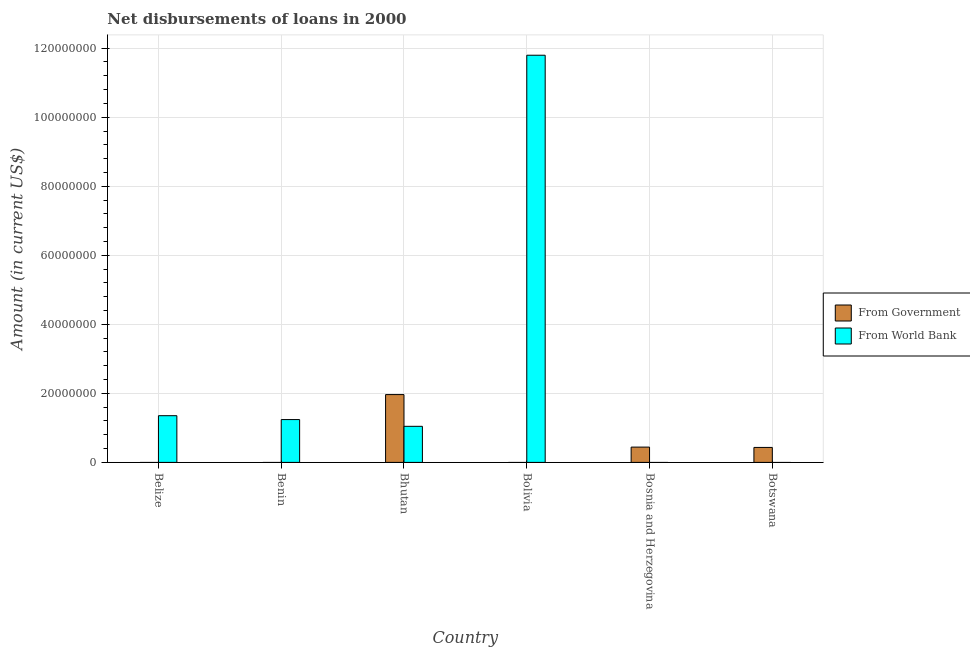Are the number of bars per tick equal to the number of legend labels?
Make the answer very short. No. How many bars are there on the 6th tick from the right?
Provide a succinct answer. 1. What is the label of the 1st group of bars from the left?
Give a very brief answer. Belize. In how many cases, is the number of bars for a given country not equal to the number of legend labels?
Provide a succinct answer. 5. What is the net disbursements of loan from government in Bhutan?
Your response must be concise. 1.96e+07. Across all countries, what is the maximum net disbursements of loan from world bank?
Provide a short and direct response. 1.18e+08. Across all countries, what is the minimum net disbursements of loan from world bank?
Ensure brevity in your answer.  0. In which country was the net disbursements of loan from government maximum?
Provide a short and direct response. Bhutan. What is the total net disbursements of loan from world bank in the graph?
Provide a succinct answer. 1.54e+08. What is the difference between the net disbursements of loan from world bank in Benin and that in Bolivia?
Provide a succinct answer. -1.06e+08. What is the difference between the net disbursements of loan from government in Bolivia and the net disbursements of loan from world bank in Bhutan?
Your answer should be compact. -1.05e+07. What is the average net disbursements of loan from world bank per country?
Give a very brief answer. 2.57e+07. What is the difference between the net disbursements of loan from world bank and net disbursements of loan from government in Bhutan?
Your response must be concise. -9.19e+06. What is the difference between the highest and the second highest net disbursements of loan from government?
Ensure brevity in your answer.  1.52e+07. What is the difference between the highest and the lowest net disbursements of loan from world bank?
Your response must be concise. 1.18e+08. How many bars are there?
Offer a very short reply. 7. Are all the bars in the graph horizontal?
Provide a succinct answer. No. How many countries are there in the graph?
Make the answer very short. 6. What is the difference between two consecutive major ticks on the Y-axis?
Make the answer very short. 2.00e+07. Does the graph contain any zero values?
Your response must be concise. Yes. Where does the legend appear in the graph?
Make the answer very short. Center right. How are the legend labels stacked?
Keep it short and to the point. Vertical. What is the title of the graph?
Offer a very short reply. Net disbursements of loans in 2000. Does "Number of arrivals" appear as one of the legend labels in the graph?
Offer a very short reply. No. What is the label or title of the X-axis?
Provide a succinct answer. Country. What is the Amount (in current US$) of From Government in Belize?
Your response must be concise. 0. What is the Amount (in current US$) in From World Bank in Belize?
Ensure brevity in your answer.  1.35e+07. What is the Amount (in current US$) of From Government in Benin?
Offer a very short reply. 0. What is the Amount (in current US$) in From World Bank in Benin?
Your answer should be very brief. 1.24e+07. What is the Amount (in current US$) in From Government in Bhutan?
Provide a succinct answer. 1.96e+07. What is the Amount (in current US$) in From World Bank in Bhutan?
Ensure brevity in your answer.  1.05e+07. What is the Amount (in current US$) of From World Bank in Bolivia?
Your answer should be compact. 1.18e+08. What is the Amount (in current US$) in From Government in Bosnia and Herzegovina?
Your answer should be very brief. 4.43e+06. What is the Amount (in current US$) in From World Bank in Bosnia and Herzegovina?
Keep it short and to the point. 0. What is the Amount (in current US$) in From Government in Botswana?
Your response must be concise. 4.34e+06. What is the Amount (in current US$) of From World Bank in Botswana?
Your answer should be very brief. 0. Across all countries, what is the maximum Amount (in current US$) of From Government?
Make the answer very short. 1.96e+07. Across all countries, what is the maximum Amount (in current US$) in From World Bank?
Keep it short and to the point. 1.18e+08. What is the total Amount (in current US$) of From Government in the graph?
Offer a terse response. 2.84e+07. What is the total Amount (in current US$) of From World Bank in the graph?
Your answer should be compact. 1.54e+08. What is the difference between the Amount (in current US$) of From World Bank in Belize and that in Benin?
Your response must be concise. 1.12e+06. What is the difference between the Amount (in current US$) of From World Bank in Belize and that in Bhutan?
Provide a succinct answer. 3.08e+06. What is the difference between the Amount (in current US$) in From World Bank in Belize and that in Bolivia?
Your answer should be very brief. -1.04e+08. What is the difference between the Amount (in current US$) in From World Bank in Benin and that in Bhutan?
Offer a terse response. 1.96e+06. What is the difference between the Amount (in current US$) of From World Bank in Benin and that in Bolivia?
Provide a short and direct response. -1.06e+08. What is the difference between the Amount (in current US$) of From World Bank in Bhutan and that in Bolivia?
Your response must be concise. -1.08e+08. What is the difference between the Amount (in current US$) in From Government in Bhutan and that in Bosnia and Herzegovina?
Provide a succinct answer. 1.52e+07. What is the difference between the Amount (in current US$) in From Government in Bhutan and that in Botswana?
Make the answer very short. 1.53e+07. What is the difference between the Amount (in current US$) of From Government in Bosnia and Herzegovina and that in Botswana?
Provide a succinct answer. 9.20e+04. What is the difference between the Amount (in current US$) of From Government in Bhutan and the Amount (in current US$) of From World Bank in Bolivia?
Offer a terse response. -9.83e+07. What is the average Amount (in current US$) in From Government per country?
Offer a terse response. 4.74e+06. What is the average Amount (in current US$) of From World Bank per country?
Your answer should be very brief. 2.57e+07. What is the difference between the Amount (in current US$) of From Government and Amount (in current US$) of From World Bank in Bhutan?
Your answer should be compact. 9.19e+06. What is the ratio of the Amount (in current US$) of From World Bank in Belize to that in Benin?
Make the answer very short. 1.09. What is the ratio of the Amount (in current US$) in From World Bank in Belize to that in Bhutan?
Make the answer very short. 1.29. What is the ratio of the Amount (in current US$) of From World Bank in Belize to that in Bolivia?
Your response must be concise. 0.11. What is the ratio of the Amount (in current US$) of From World Bank in Benin to that in Bhutan?
Your answer should be compact. 1.19. What is the ratio of the Amount (in current US$) in From World Bank in Benin to that in Bolivia?
Make the answer very short. 0.11. What is the ratio of the Amount (in current US$) in From World Bank in Bhutan to that in Bolivia?
Make the answer very short. 0.09. What is the ratio of the Amount (in current US$) of From Government in Bhutan to that in Bosnia and Herzegovina?
Your answer should be very brief. 4.43. What is the ratio of the Amount (in current US$) in From Government in Bhutan to that in Botswana?
Provide a succinct answer. 4.53. What is the ratio of the Amount (in current US$) in From Government in Bosnia and Herzegovina to that in Botswana?
Make the answer very short. 1.02. What is the difference between the highest and the second highest Amount (in current US$) in From Government?
Your response must be concise. 1.52e+07. What is the difference between the highest and the second highest Amount (in current US$) in From World Bank?
Your answer should be very brief. 1.04e+08. What is the difference between the highest and the lowest Amount (in current US$) of From Government?
Your answer should be very brief. 1.96e+07. What is the difference between the highest and the lowest Amount (in current US$) of From World Bank?
Give a very brief answer. 1.18e+08. 